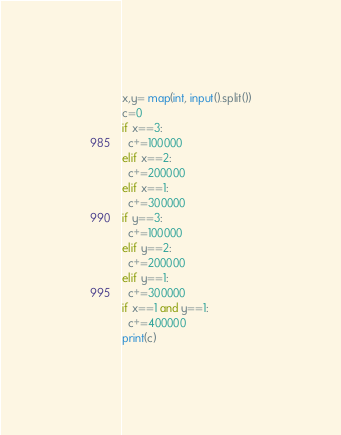Convert code to text. <code><loc_0><loc_0><loc_500><loc_500><_Python_>x,y= map(int, input().split())
c=0
if x==3:
  c+=100000
elif x==2:
  c+=200000
elif x==1:
  c+=300000
if y==3:
  c+=100000
elif y==2:
  c+=200000
elif y==1:
  c+=300000
if x==1 and y==1:
  c+=400000
print(c)</code> 